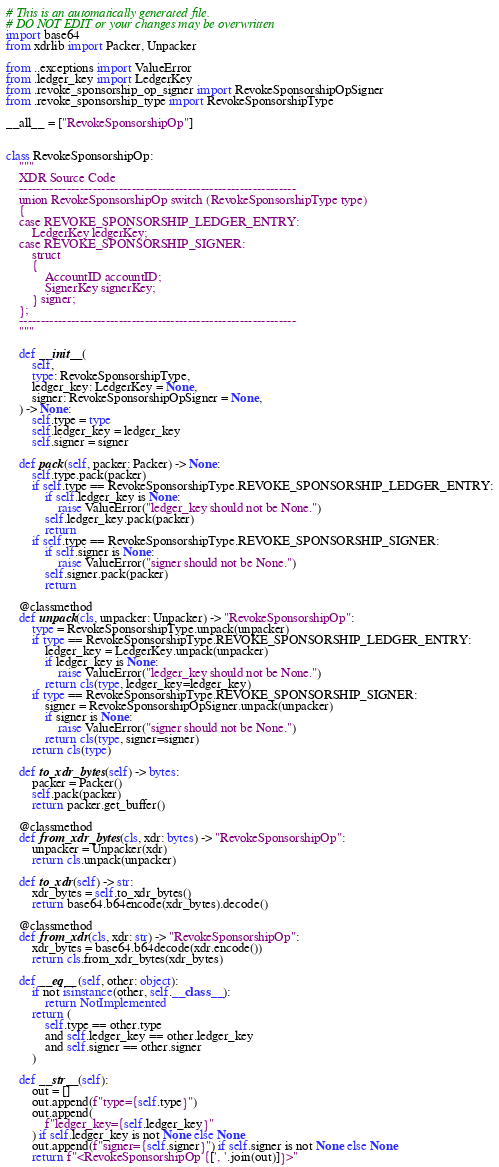<code> <loc_0><loc_0><loc_500><loc_500><_Python_># This is an automatically generated file.
# DO NOT EDIT or your changes may be overwritten
import base64
from xdrlib import Packer, Unpacker

from ..exceptions import ValueError
from .ledger_key import LedgerKey
from .revoke_sponsorship_op_signer import RevokeSponsorshipOpSigner
from .revoke_sponsorship_type import RevokeSponsorshipType

__all__ = ["RevokeSponsorshipOp"]


class RevokeSponsorshipOp:
    """
    XDR Source Code
    ----------------------------------------------------------------
    union RevokeSponsorshipOp switch (RevokeSponsorshipType type)
    {
    case REVOKE_SPONSORSHIP_LEDGER_ENTRY:
        LedgerKey ledgerKey;
    case REVOKE_SPONSORSHIP_SIGNER:
        struct
        {
            AccountID accountID;
            SignerKey signerKey;
        } signer;
    };
    ----------------------------------------------------------------
    """

    def __init__(
        self,
        type: RevokeSponsorshipType,
        ledger_key: LedgerKey = None,
        signer: RevokeSponsorshipOpSigner = None,
    ) -> None:
        self.type = type
        self.ledger_key = ledger_key
        self.signer = signer

    def pack(self, packer: Packer) -> None:
        self.type.pack(packer)
        if self.type == RevokeSponsorshipType.REVOKE_SPONSORSHIP_LEDGER_ENTRY:
            if self.ledger_key is None:
                raise ValueError("ledger_key should not be None.")
            self.ledger_key.pack(packer)
            return
        if self.type == RevokeSponsorshipType.REVOKE_SPONSORSHIP_SIGNER:
            if self.signer is None:
                raise ValueError("signer should not be None.")
            self.signer.pack(packer)
            return

    @classmethod
    def unpack(cls, unpacker: Unpacker) -> "RevokeSponsorshipOp":
        type = RevokeSponsorshipType.unpack(unpacker)
        if type == RevokeSponsorshipType.REVOKE_SPONSORSHIP_LEDGER_ENTRY:
            ledger_key = LedgerKey.unpack(unpacker)
            if ledger_key is None:
                raise ValueError("ledger_key should not be None.")
            return cls(type, ledger_key=ledger_key)
        if type == RevokeSponsorshipType.REVOKE_SPONSORSHIP_SIGNER:
            signer = RevokeSponsorshipOpSigner.unpack(unpacker)
            if signer is None:
                raise ValueError("signer should not be None.")
            return cls(type, signer=signer)
        return cls(type)

    def to_xdr_bytes(self) -> bytes:
        packer = Packer()
        self.pack(packer)
        return packer.get_buffer()

    @classmethod
    def from_xdr_bytes(cls, xdr: bytes) -> "RevokeSponsorshipOp":
        unpacker = Unpacker(xdr)
        return cls.unpack(unpacker)

    def to_xdr(self) -> str:
        xdr_bytes = self.to_xdr_bytes()
        return base64.b64encode(xdr_bytes).decode()

    @classmethod
    def from_xdr(cls, xdr: str) -> "RevokeSponsorshipOp":
        xdr_bytes = base64.b64decode(xdr.encode())
        return cls.from_xdr_bytes(xdr_bytes)

    def __eq__(self, other: object):
        if not isinstance(other, self.__class__):
            return NotImplemented
        return (
            self.type == other.type
            and self.ledger_key == other.ledger_key
            and self.signer == other.signer
        )

    def __str__(self):
        out = []
        out.append(f"type={self.type}")
        out.append(
            f"ledger_key={self.ledger_key}"
        ) if self.ledger_key is not None else None
        out.append(f"signer={self.signer}") if self.signer is not None else None
        return f"<RevokeSponsorshipOp {[', '.join(out)]}>"
</code> 